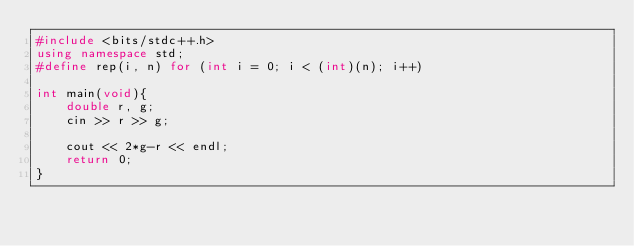<code> <loc_0><loc_0><loc_500><loc_500><_C++_>#include <bits/stdc++.h>
using namespace std;
#define rep(i, n) for (int i = 0; i < (int)(n); i++)

int main(void){
    double r, g;
    cin >> r >> g;

    cout << 2*g-r << endl;
    return 0;
}</code> 